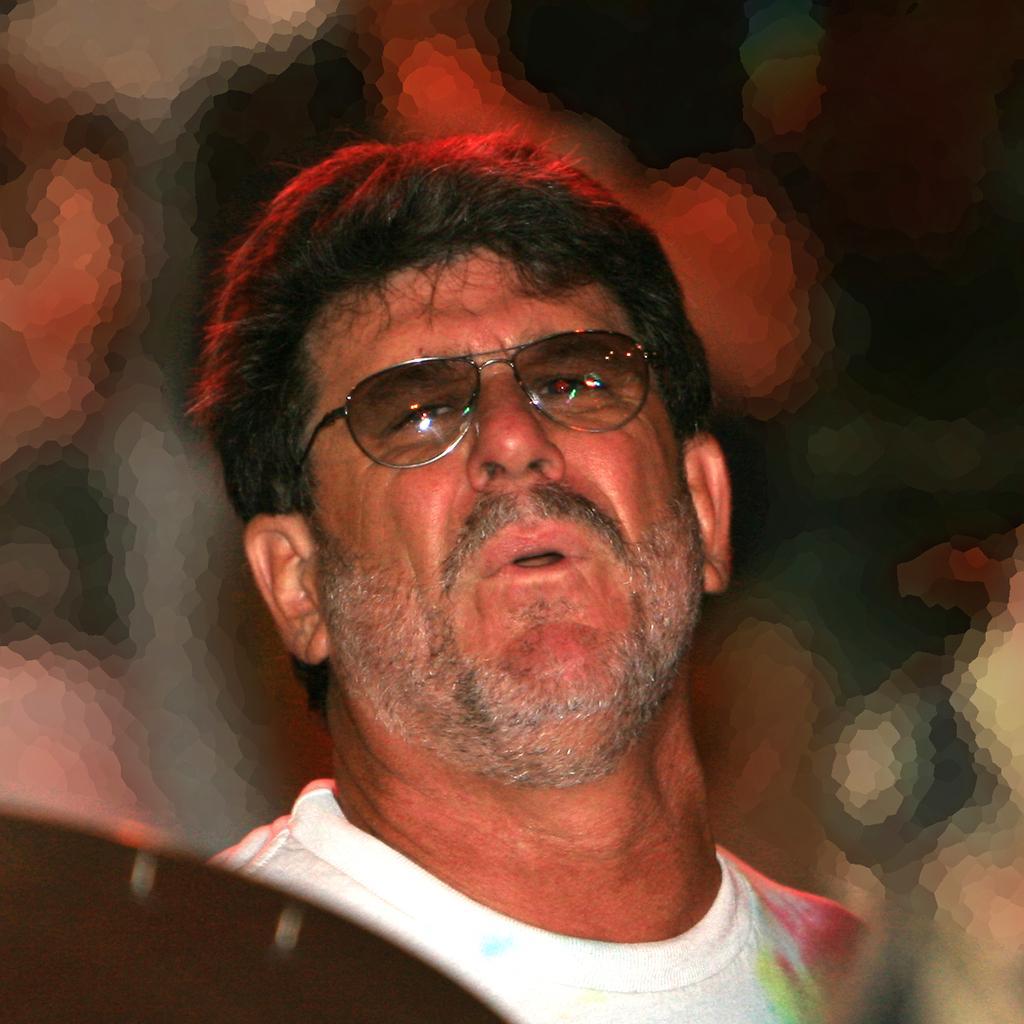Describe this image in one or two sentences. In this image I can see a person wearing white t shirt and spectacles and I can see the blurry background. 